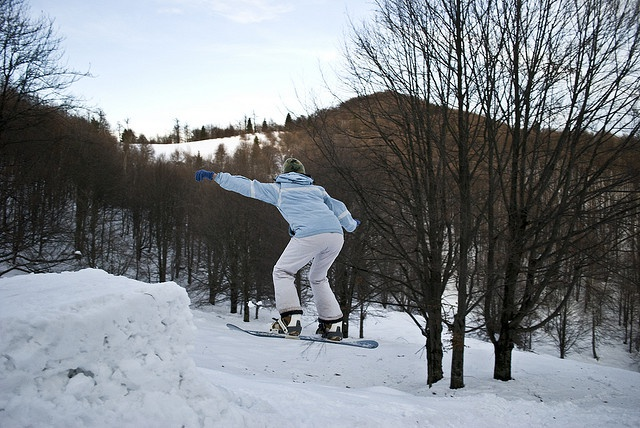Describe the objects in this image and their specific colors. I can see people in navy, darkgray, black, and gray tones and snowboard in navy, darkgray, and gray tones in this image. 